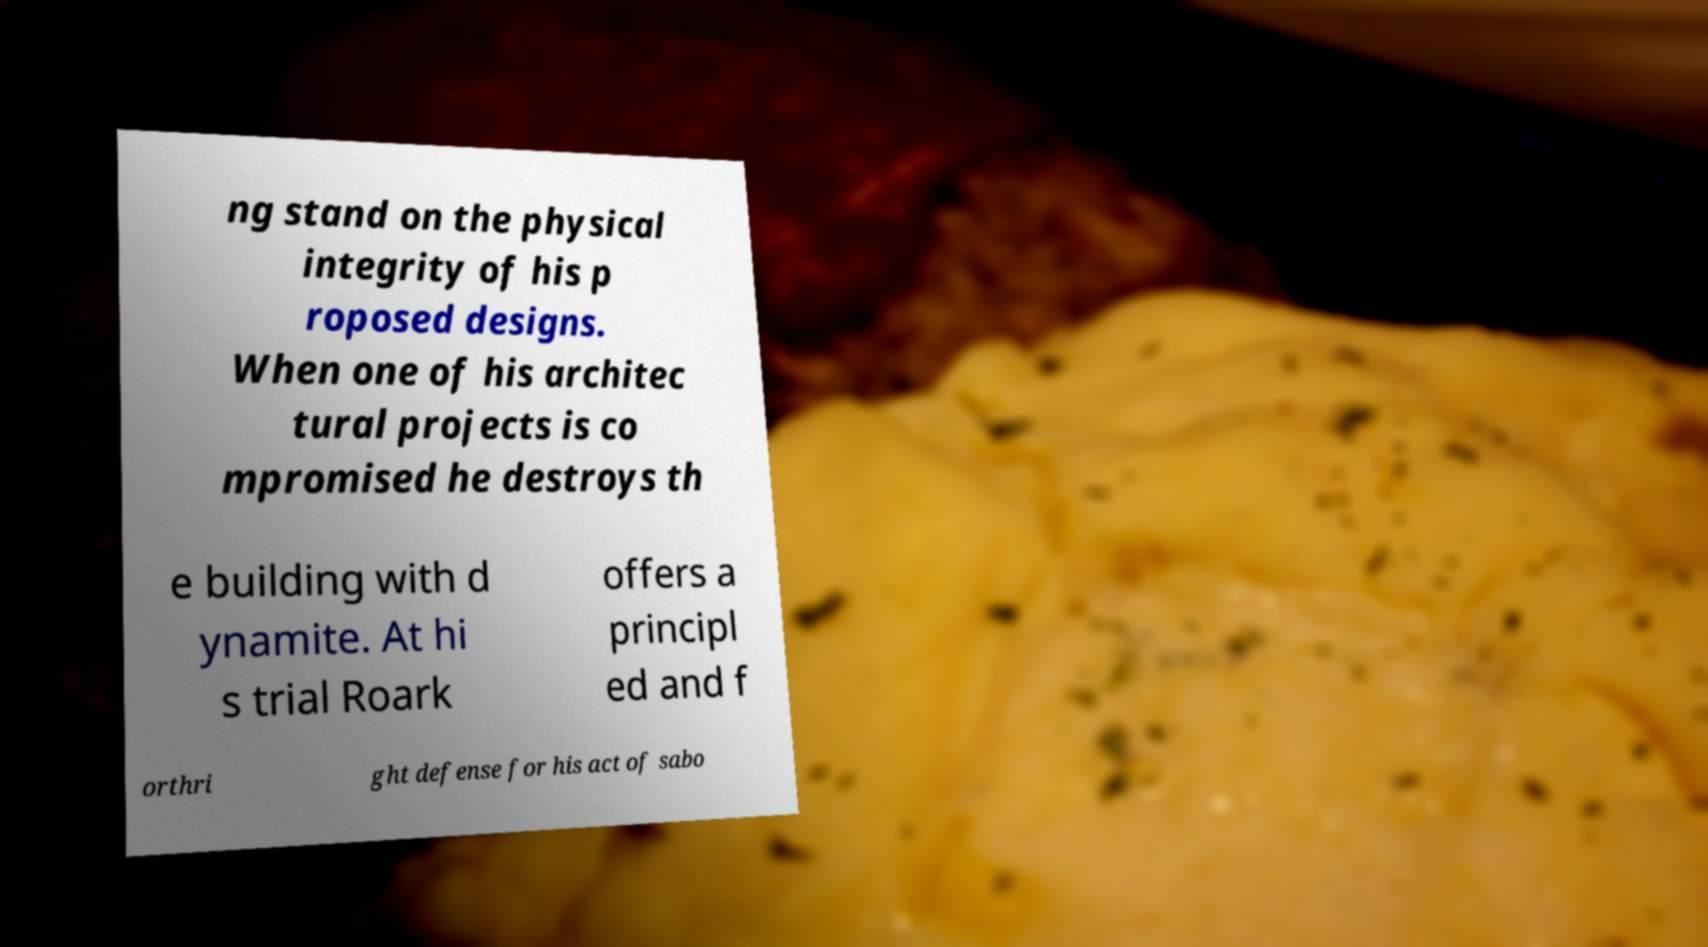Please identify and transcribe the text found in this image. ng stand on the physical integrity of his p roposed designs. When one of his architec tural projects is co mpromised he destroys th e building with d ynamite. At hi s trial Roark offers a principl ed and f orthri ght defense for his act of sabo 